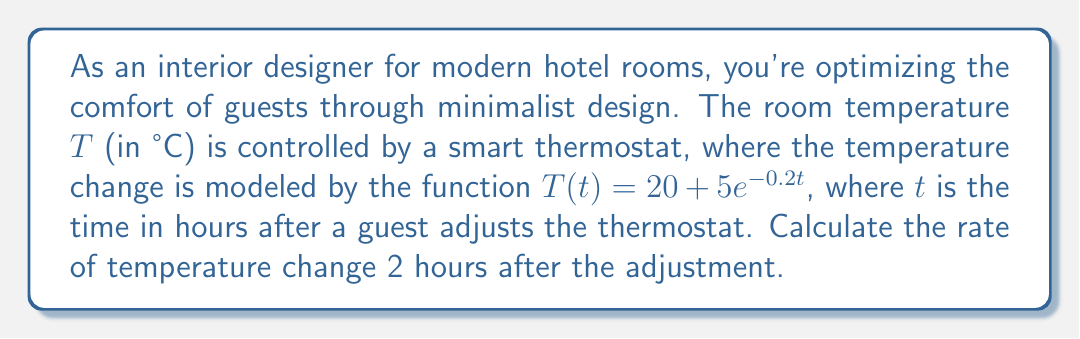Show me your answer to this math problem. To find the rate of temperature change, we need to calculate the derivative of the temperature function $T(t)$ and then evaluate it at $t = 2$ hours.

Step 1: Calculate the derivative of $T(t)$
$$\frac{d}{dt}T(t) = \frac{d}{dt}(20 + 5e^{-0.2t})$$
$$T'(t) = 0 + 5 \cdot (-0.2)e^{-0.2t}$$
$$T'(t) = -e^{-0.2t}$$

Step 2: Evaluate $T'(t)$ at $t = 2$
$$T'(2) = -e^{-0.2(2)}$$
$$T'(2) = -e^{-0.4}$$
$$T'(2) \approx -0.67 \text{ °C/hour}$$

The negative value indicates that the temperature is decreasing.
Answer: $-0.67$ °C/hour 